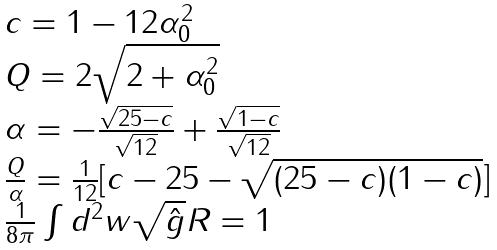Convert formula to latex. <formula><loc_0><loc_0><loc_500><loc_500>\begin{array} { l } c = 1 - 1 2 \alpha _ { 0 } ^ { 2 } \\ Q = 2 \sqrt { 2 + \alpha _ { 0 } ^ { 2 } } \\ \alpha = - \frac { \sqrt { 2 5 - c } } { \sqrt { 1 2 } } + \frac { \sqrt { 1 - c } } { \sqrt { 1 2 } } \\ \frac { Q } { \alpha } = \frac { 1 } { 1 2 } [ c - 2 5 - \sqrt { ( 2 5 - c ) ( 1 - c ) } ] \\ \frac { 1 } { 8 \pi } \int d ^ { 2 } w \sqrt { \hat { g } } R = 1 \end{array}</formula> 